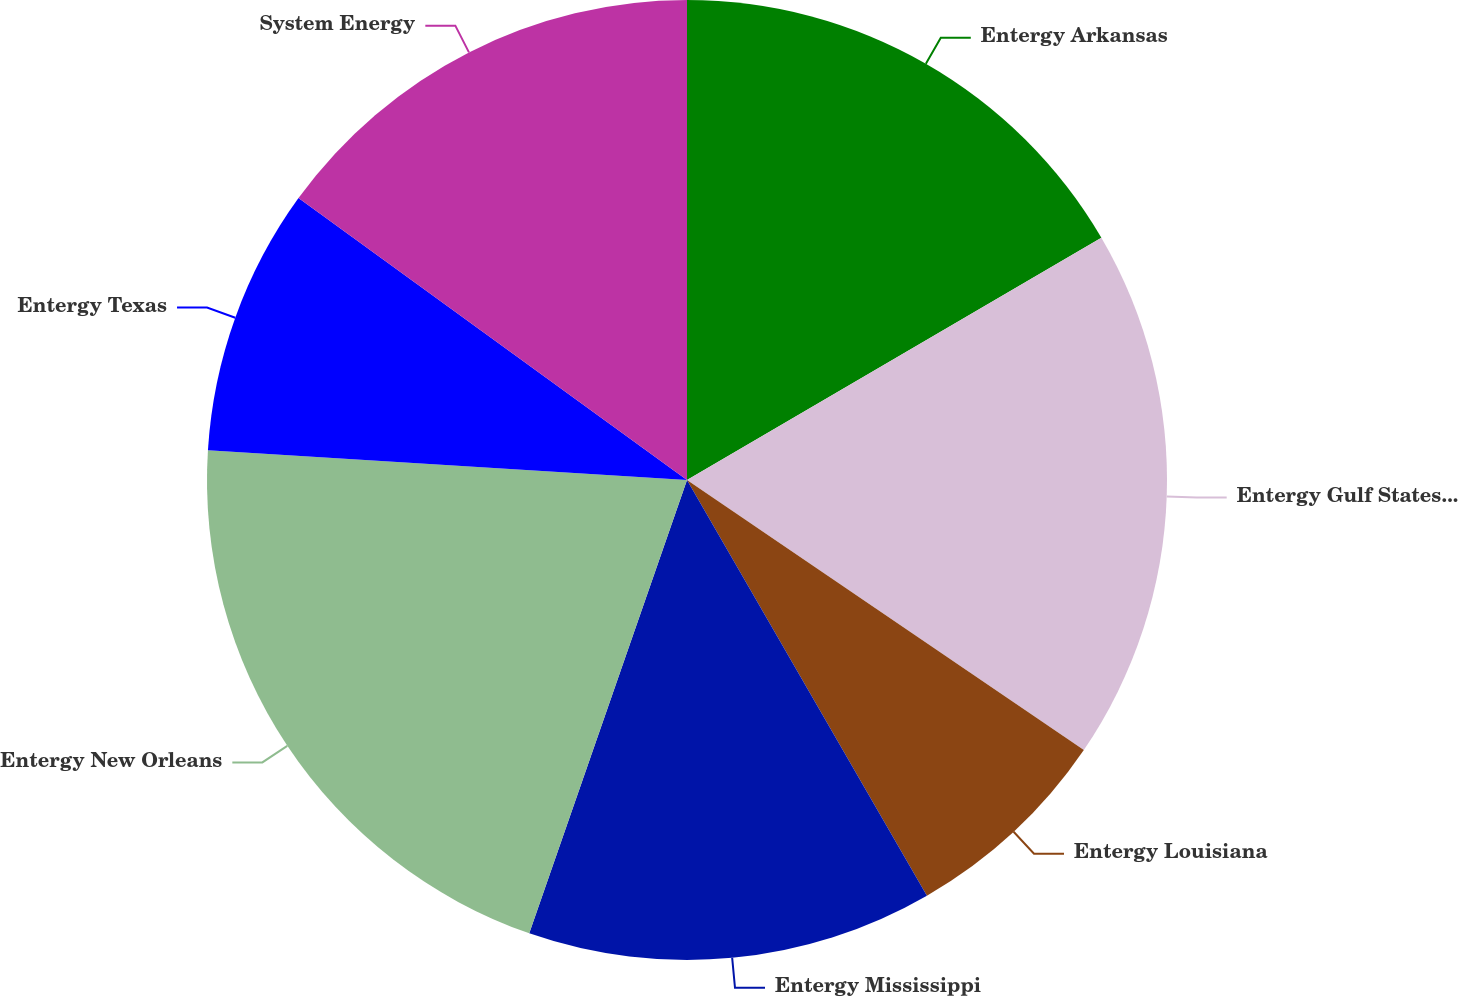Convert chart. <chart><loc_0><loc_0><loc_500><loc_500><pie_chart><fcel>Entergy Arkansas<fcel>Entergy Gulf States Louisiana<fcel>Entergy Louisiana<fcel>Entergy Mississippi<fcel>Entergy New Orleans<fcel>Entergy Texas<fcel>System Energy<nl><fcel>16.58%<fcel>17.93%<fcel>7.16%<fcel>13.66%<fcel>20.66%<fcel>9.0%<fcel>15.01%<nl></chart> 